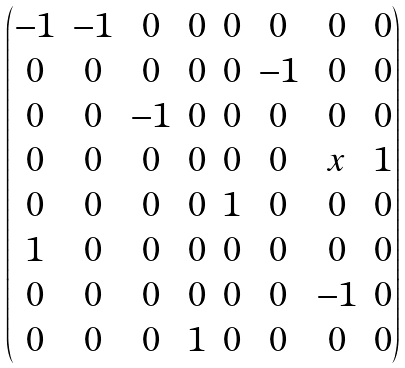Convert formula to latex. <formula><loc_0><loc_0><loc_500><loc_500>\begin{pmatrix} - 1 & - 1 & 0 & 0 & 0 & 0 & 0 & 0 \\ 0 & 0 & 0 & 0 & 0 & - 1 & 0 & 0 \\ 0 & 0 & - 1 & 0 & 0 & 0 & 0 & 0 \\ 0 & 0 & 0 & 0 & 0 & 0 & x & 1 \\ 0 & 0 & 0 & 0 & 1 & 0 & 0 & 0 \\ 1 & 0 & 0 & 0 & 0 & 0 & 0 & 0 \\ 0 & 0 & 0 & 0 & 0 & 0 & - 1 & 0 \\ 0 & 0 & 0 & 1 & 0 & 0 & 0 & 0 \end{pmatrix}</formula> 